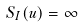<formula> <loc_0><loc_0><loc_500><loc_500>S _ { I } ( u ) = \infty</formula> 